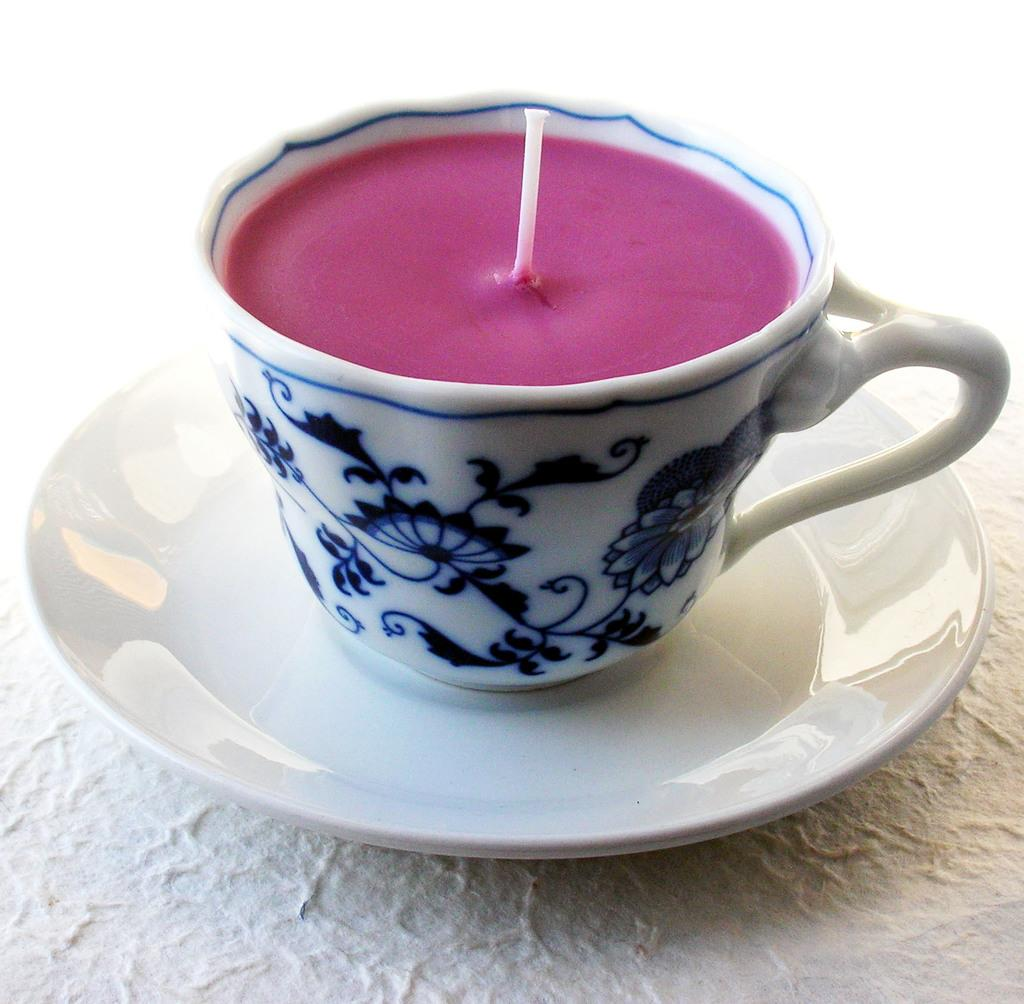What is in the image that can hold liquids? There is a cup in the image that can hold liquids. Is the cup placed on any other object? Yes, the cup is placed on a saucer. What substance is inside the cup? There is wax in the cup. What is visible on the surface of the wax? A thread is present on the surface of the wax. Is there a dog holding an umbrella over the cup in the image? No, there is no dog or umbrella present in the image. 